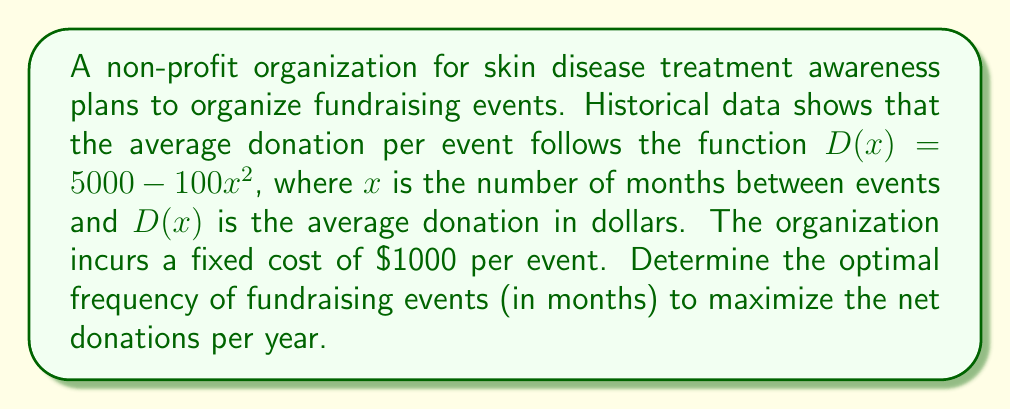What is the answer to this math problem? To solve this optimization problem, we need to follow these steps:

1. Define the objective function:
Let $f(x)$ be the net donation per year.
$$f(x) = \frac{12}{x}(D(x) - 1000)$$
Where $\frac{12}{x}$ is the number of events per year, and $(D(x) - 1000)$ is the net donation per event.

2. Substitute $D(x)$ into the function:
$$f(x) = \frac{12}{x}(5000 - 100x^2 - 1000)$$
$$f(x) = \frac{12}{x}(4000 - 100x^2)$$

3. Expand the function:
$$f(x) = 48000x^{-1} - 1200x$$

4. To find the maximum, we need to find where $f'(x) = 0$:
$$f'(x) = -48000x^{-2} - 1200$$

5. Set $f'(x) = 0$ and solve for $x$:
$$-48000x^{-2} - 1200 = 0$$
$$-48000x^{-2} = 1200$$
$$x^{-2} = \frac{1200}{48000} = \frac{1}{40}$$
$$x^2 = 40$$
$$x = \sqrt{40} \approx 6.32$$

6. Verify this is a maximum by checking the second derivative:
$$f''(x) = 96000x^{-3}$$
At $x = \sqrt{40}$, $f''(x) > 0$, confirming this is a local minimum.

7. Since $x$ represents months, we need to round to the nearest whole number:
$x \approx 6$ months
Answer: The optimal frequency for fundraising events is approximately 6 months to maximize net donations per year. 